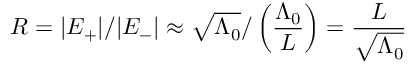Convert formula to latex. <formula><loc_0><loc_0><loc_500><loc_500>R = | E _ { + } | / | E _ { - } | \approx \sqrt { \Lambda _ { 0 } } / \left ( \frac { \Lambda _ { 0 } } { L } \right ) = \frac { L } { \sqrt { \Lambda _ { 0 } } }</formula> 